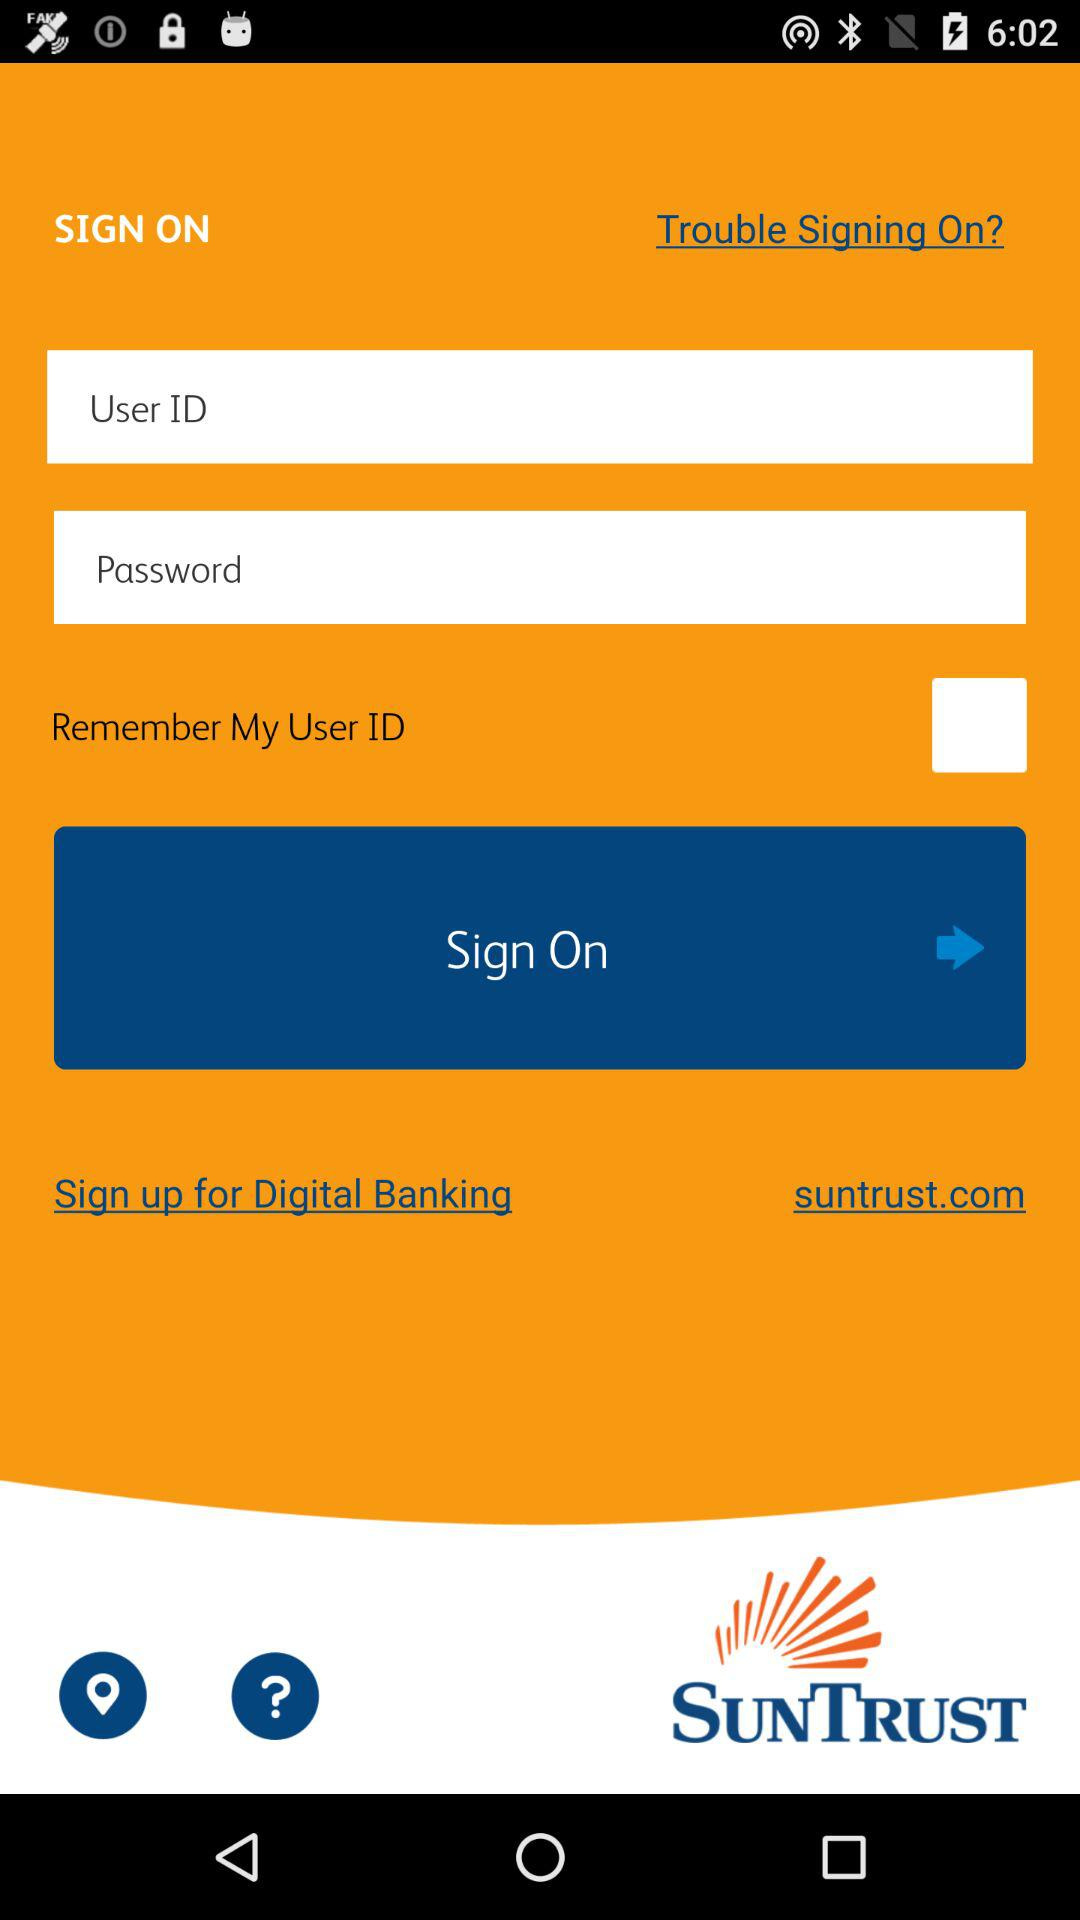What can a user sign up for? A user can sign up for digital banking. 